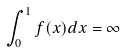Convert formula to latex. <formula><loc_0><loc_0><loc_500><loc_500>\int _ { 0 } ^ { 1 } f ( x ) d x = \infty</formula> 